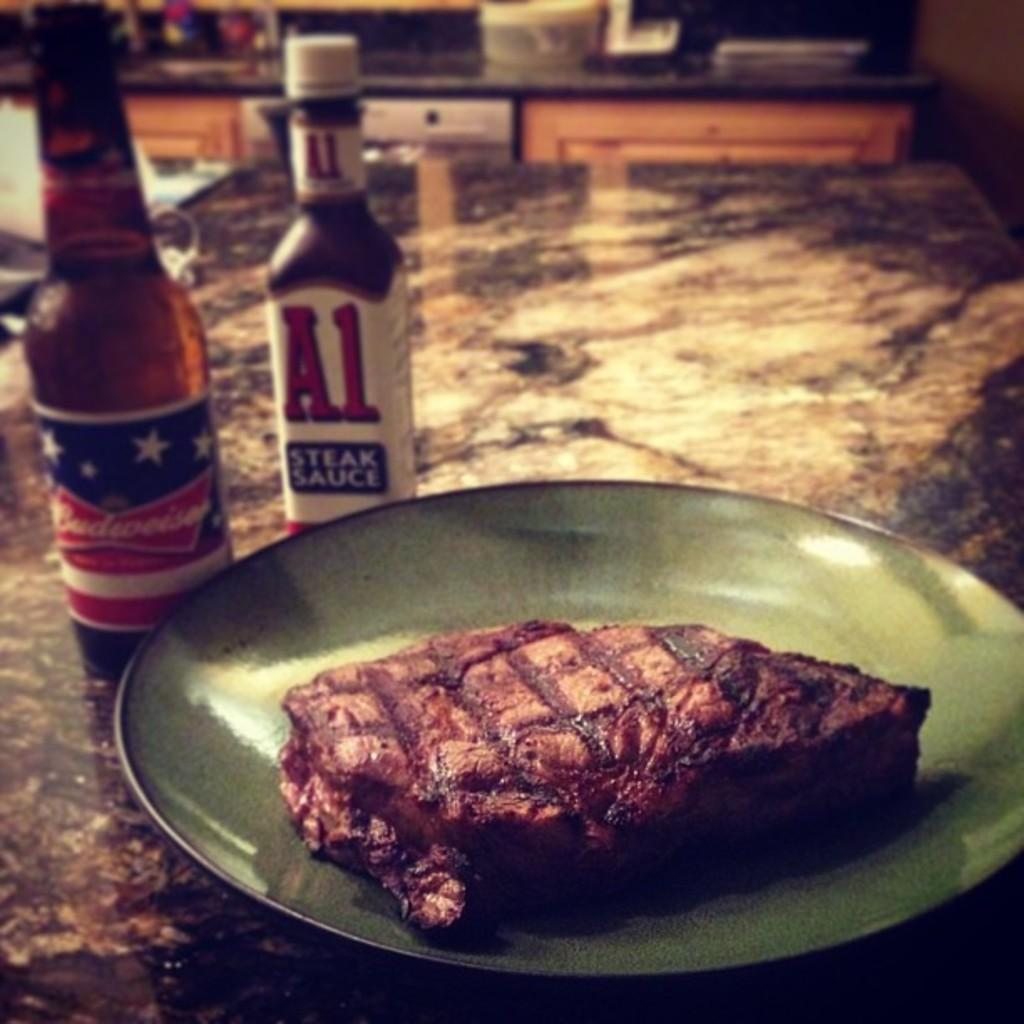<image>
Offer a succinct explanation of the picture presented. A Budweiser beer and a bottle of A1 steak sauce next to a green plate with a single steak on it. 